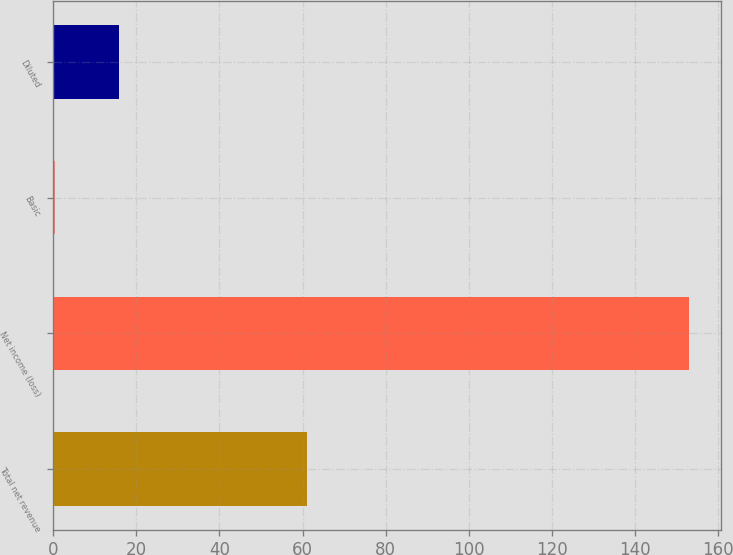Convert chart. <chart><loc_0><loc_0><loc_500><loc_500><bar_chart><fcel>Total net revenue<fcel>Net income (loss)<fcel>Basic<fcel>Diluted<nl><fcel>61<fcel>153<fcel>0.53<fcel>15.78<nl></chart> 